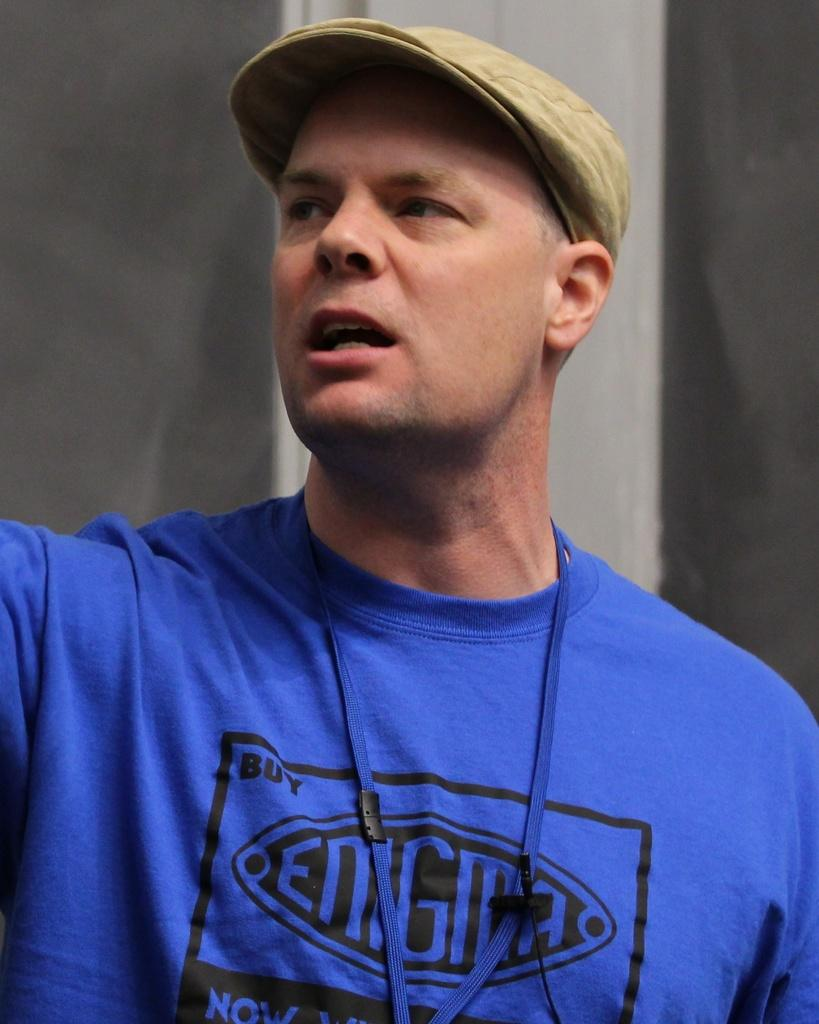<image>
Present a compact description of the photo's key features. a man wearring a blue shirt that has ENIGMA on the front 